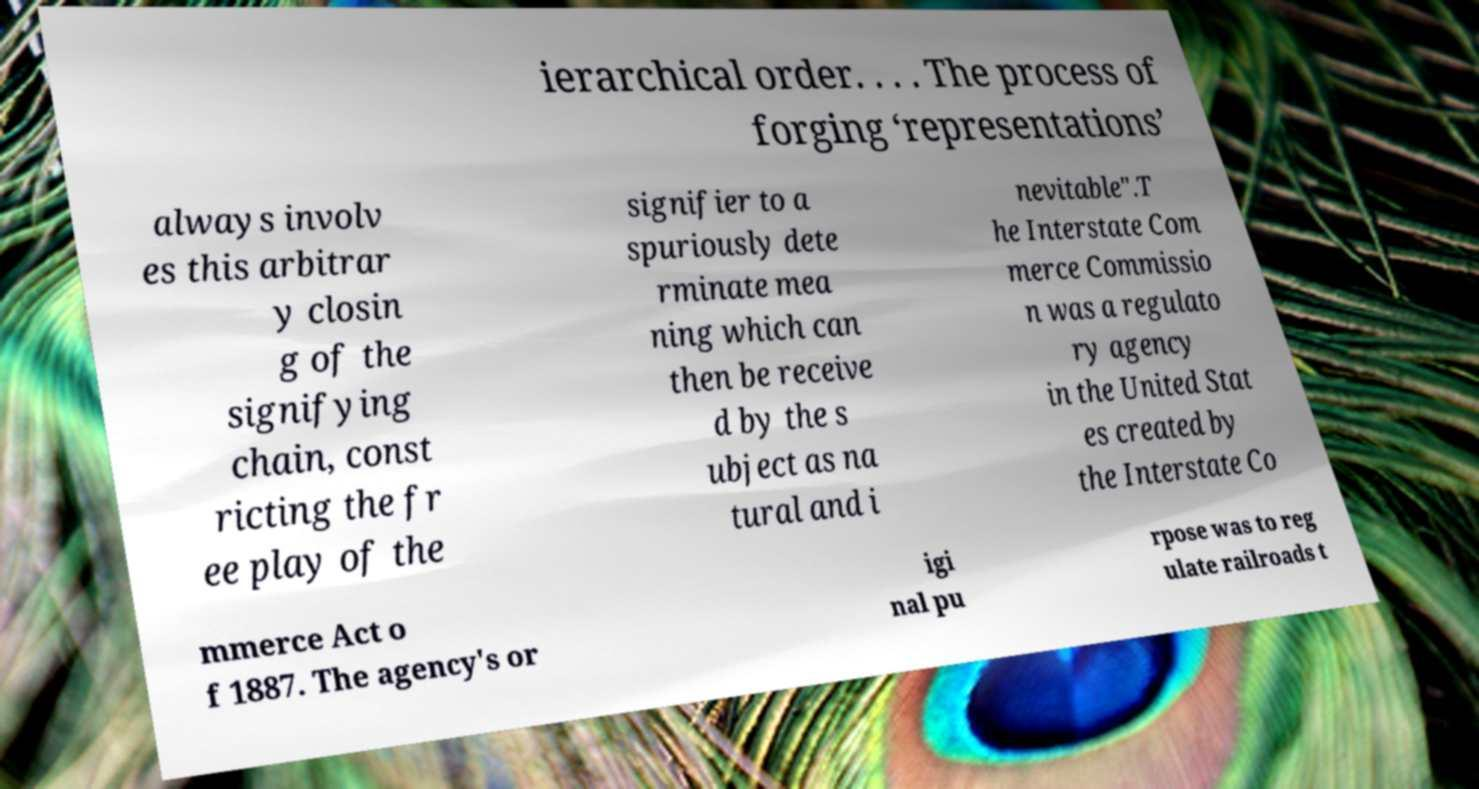Please identify and transcribe the text found in this image. ierarchical order. . . . The process of forging ‘representations’ always involv es this arbitrar y closin g of the signifying chain, const ricting the fr ee play of the signifier to a spuriously dete rminate mea ning which can then be receive d by the s ubject as na tural and i nevitable".T he Interstate Com merce Commissio n was a regulato ry agency in the United Stat es created by the Interstate Co mmerce Act o f 1887. The agency's or igi nal pu rpose was to reg ulate railroads t 